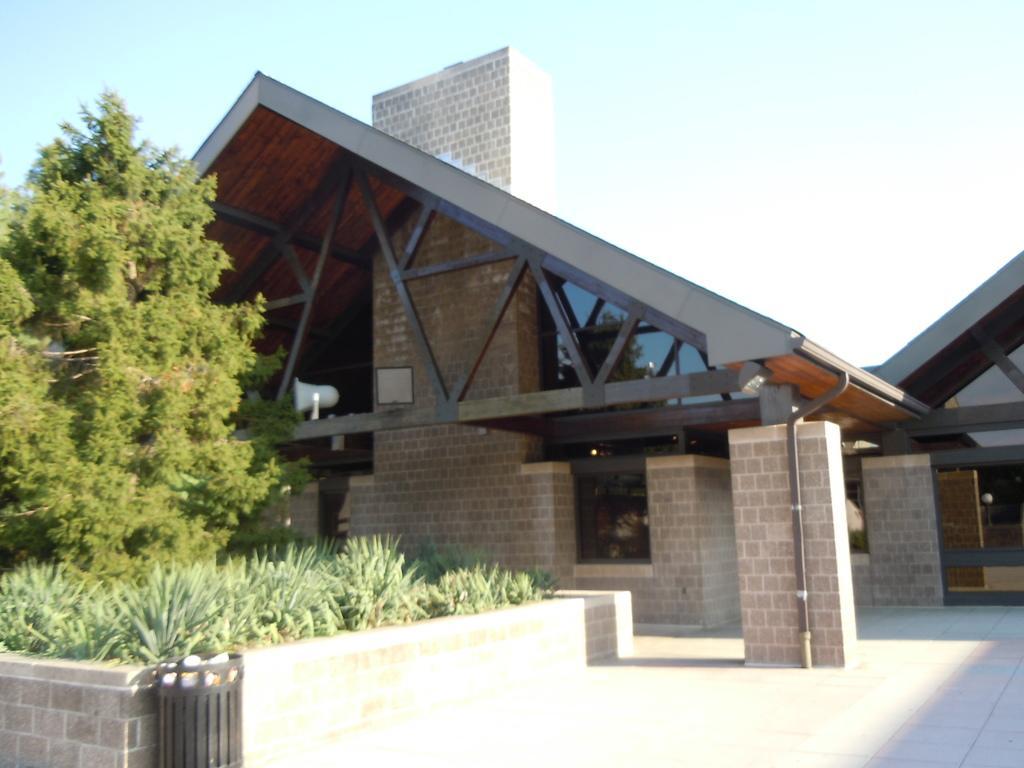Could you give a brief overview of what you see in this image? In this image in the front there are plants and in the background there is a building. On the left side there is a tree and the sky is cloudy. 